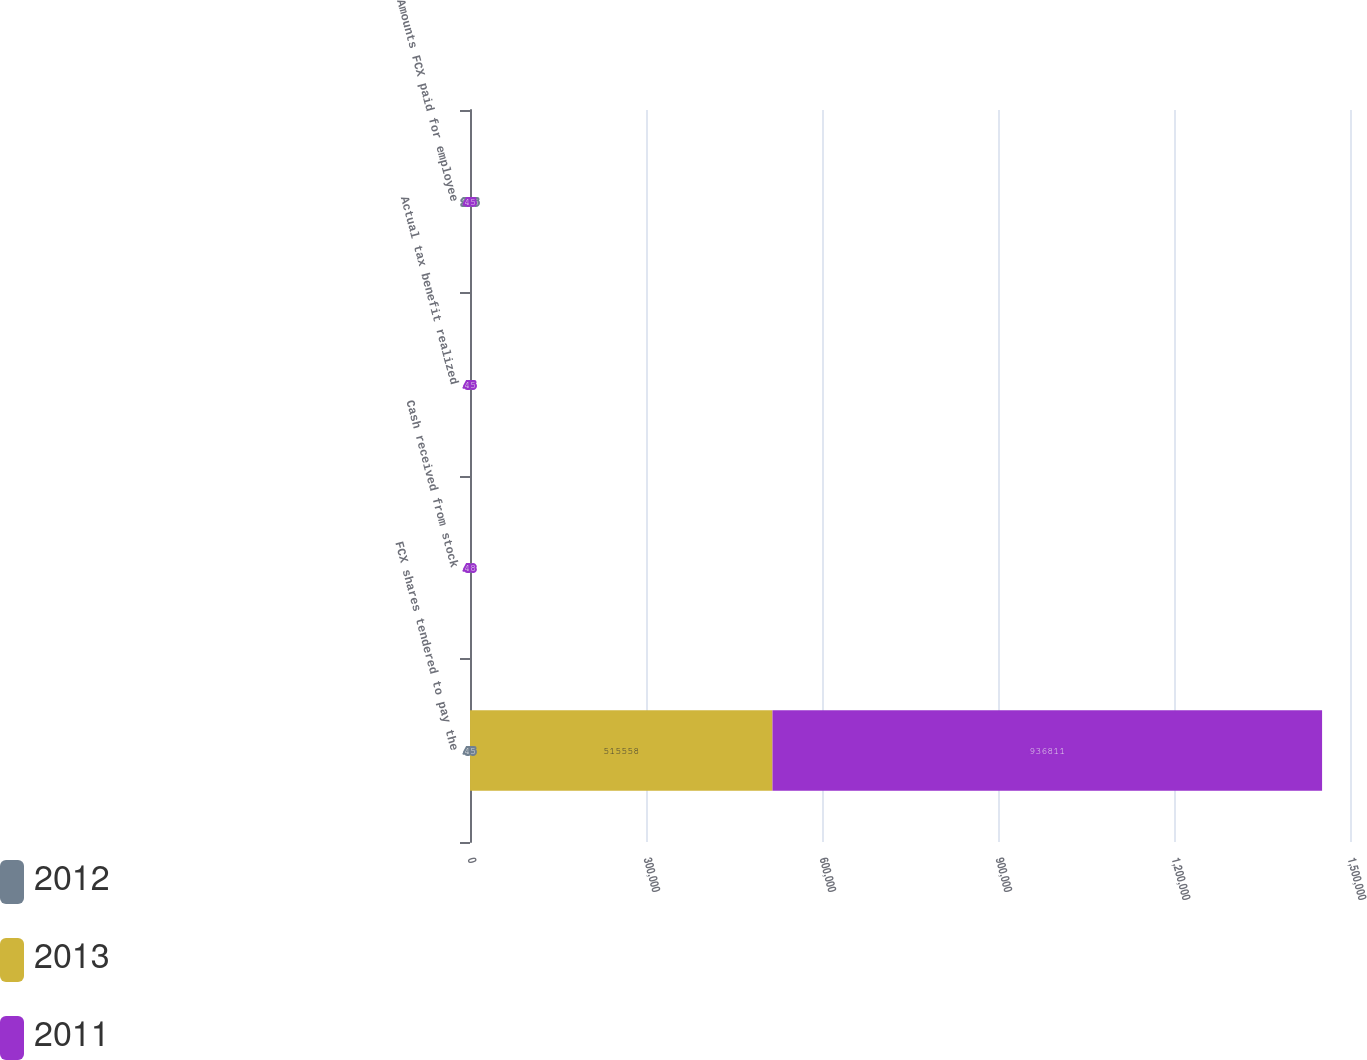Convert chart. <chart><loc_0><loc_0><loc_500><loc_500><stacked_bar_chart><ecel><fcel>FCX shares tendered to pay the<fcel>Cash received from stock<fcel>Actual tax benefit realized<fcel>Amounts FCX paid for employee<nl><fcel>2012<fcel>45<fcel>8<fcel>8<fcel>105<nl><fcel>2013<fcel>515558<fcel>15<fcel>16<fcel>16<nl><fcel>2011<fcel>936811<fcel>48<fcel>45<fcel>45<nl></chart> 